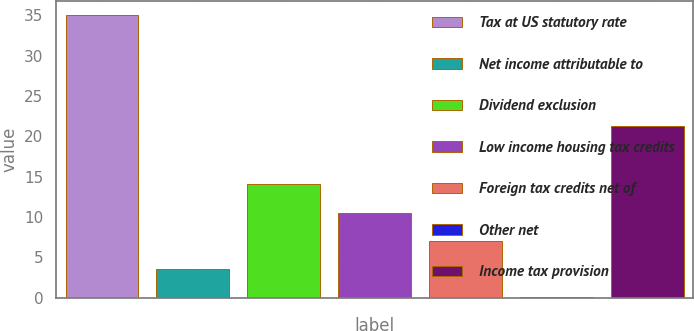<chart> <loc_0><loc_0><loc_500><loc_500><bar_chart><fcel>Tax at US statutory rate<fcel>Net income attributable to<fcel>Dividend exclusion<fcel>Low income housing tax credits<fcel>Foreign tax credits net of<fcel>Other net<fcel>Income tax provision<nl><fcel>35<fcel>3.59<fcel>14.06<fcel>10.57<fcel>7.08<fcel>0.1<fcel>21.3<nl></chart> 